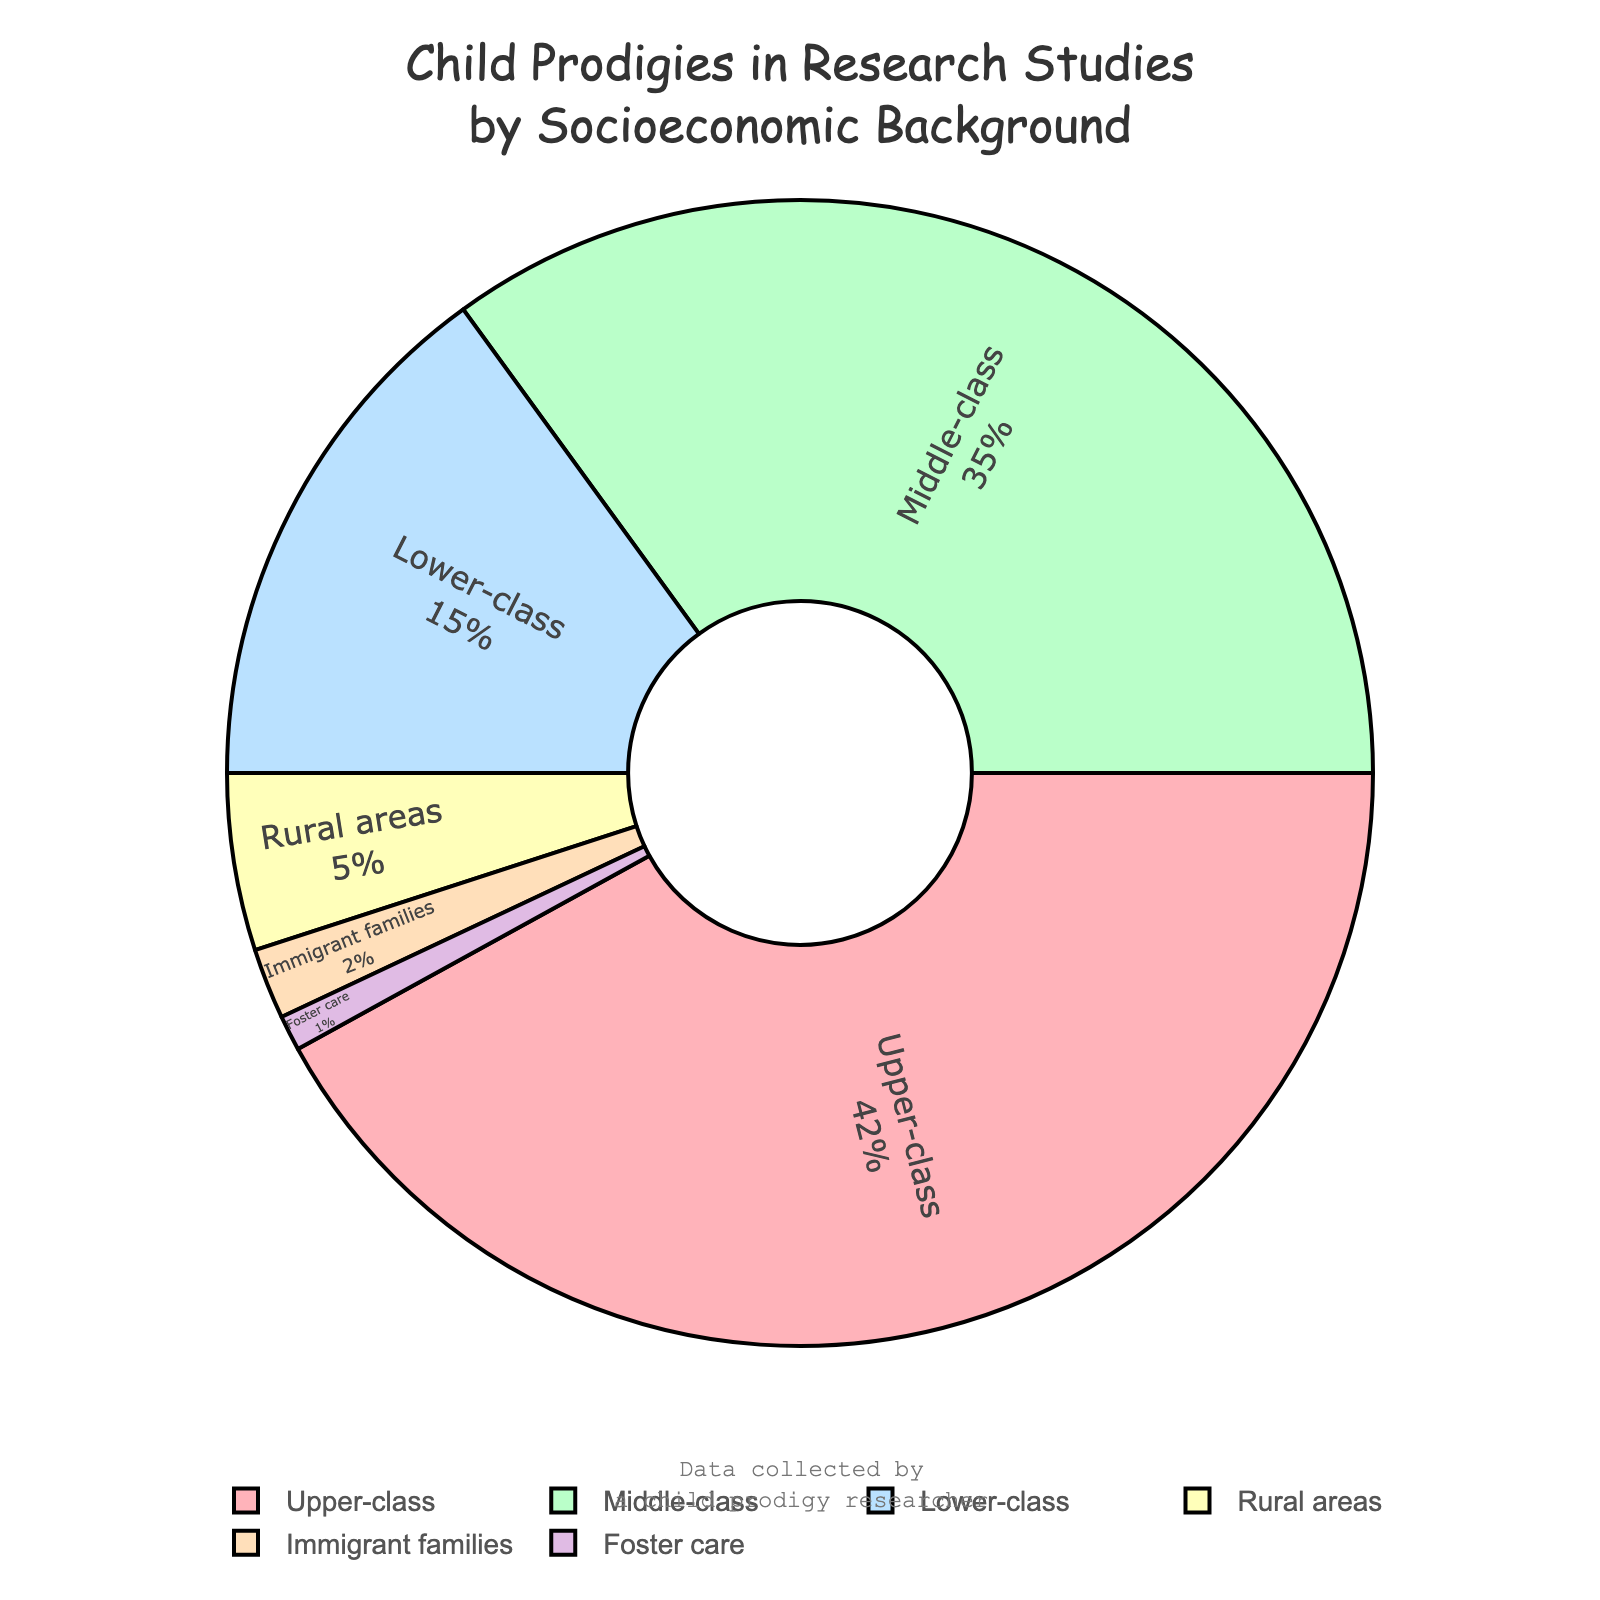What percentage of child prodigies in research studies come from upper-class backgrounds? To determine the percentage, refer directly to the chart section labeled "Upper-class". The label indicates 42%.
Answer: 42% Which socioeconomic background has the smallest representation of child prodigies in the research studies? Look for the smallest segment in the pie chart, which corresponds to the label "Foster care" and shows 1%.
Answer: Foster care What is the combined percentage of child prodigies from rural areas and immigrant families? Add the percentages for "Rural areas" (5%) and "Immigrant families" (2%). The total is 5% + 2% = 7%.
Answer: 7% How does the representation of child prodigies from the middle-class background compare to that from the lower-class background? Compare the segments labeled "Middle-class" and "Lower-class". The middle-class segment shows 35%, and the lower-class segment shows 15%. Thus, the middle-class representation is greater.
Answer: Middle-class > Lower-class What are the colors used for the representations of upper-class and lower-class backgrounds? Identify the visual attributes: The upper-class section is colored in light pink, and the lower-class section is colored in light blue.
Answer: Light pink (upper-class), Light blue (lower-class) How much more representation do child prodigies from upper-class backgrounds have compared to those from middle-class backgrounds? Subtract the middle-class percentage (35%) from the upper-class percentage (42%). The difference is 42% - 35% = 7%.
Answer: 7% What is the percentage representation of child prodigies from foster care and rural areas combined? Add the percentages for "Foster care" (1%) and "Rural areas" (5%). The total is 1% + 5% = 6%.
Answer: 6% If the total number of child prodigies studied is 200, how many of them come from lower-class backgrounds? Find the portion of 200 corresponding to the lower-class percentage (15%). Calculate 200 * 0.15 = 30.
Answer: 30 